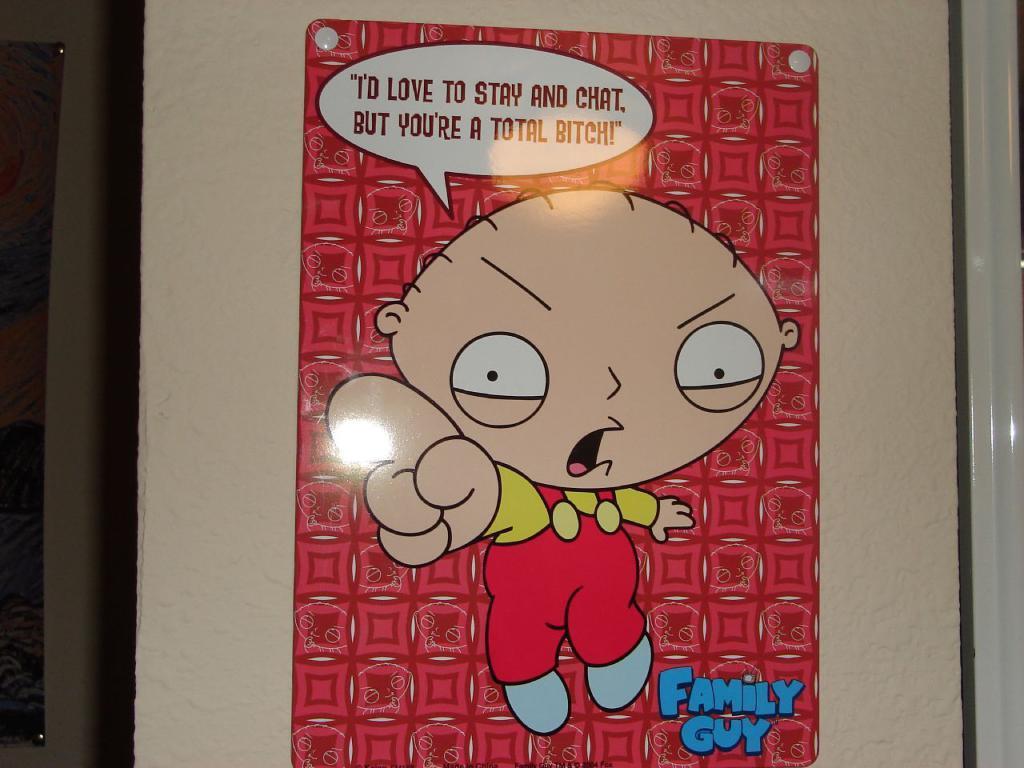Please provide a concise description of this image. In this picture we can see a poster on the wall and on poster we can see an animated picture. 